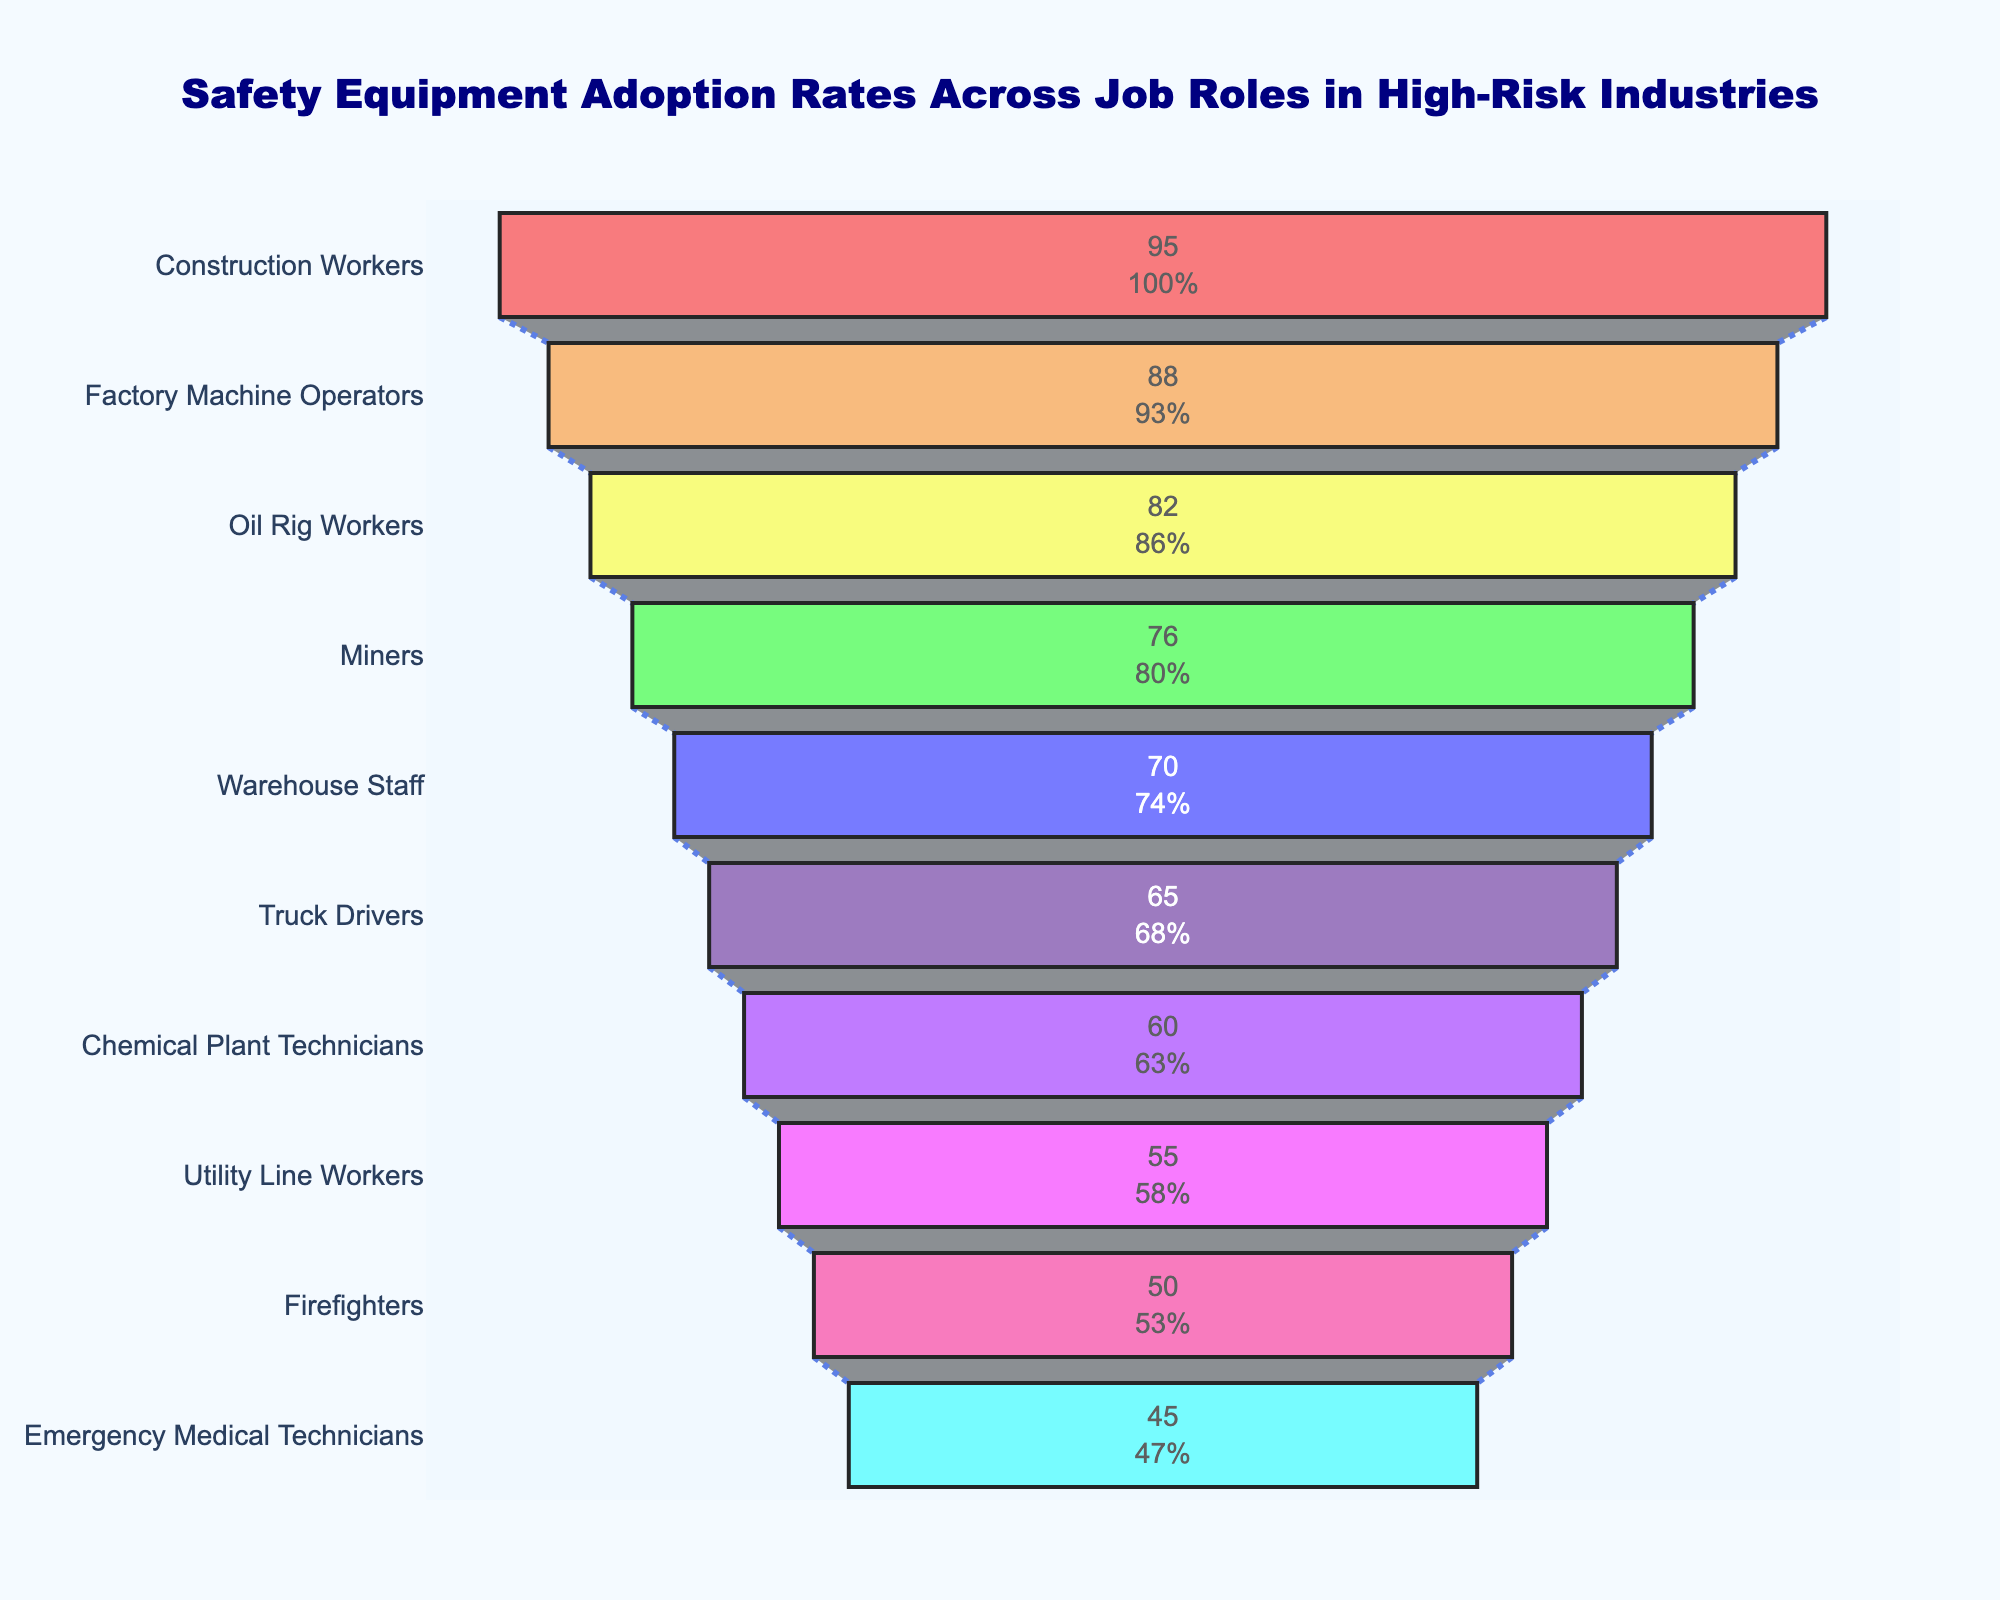What is the title of the chart? The title of the chart is usually placed at the top and provides an overview of what the chart represents. In this case, the title is "Safety Equipment Adoption Rates Across Job Roles in High-Risk Industries".
Answer: Safety Equipment Adoption Rates Across Job Roles in High-Risk Industries How many job roles are included in the funnel chart? By visually counting the distinct sections or categories listed on the left side of the chart, each representing a job role, one can determine the number of job roles included. In this case, there are ten.
Answer: 10 Which job role has the highest adoption rate for safety equipment? The funnel chart descends from the highest to the lowest adoption rate. The top category represents the job role with the highest rate, which is "Construction Workers" with 95%.
Answer: Construction Workers Which job role has the lowest adoption rate for safety equipment? The lowest adoption rate is shown at the bottom of the funnel chart. In this case, "Emergency Medical Technicians" are at the bottom, indicating the lowest adoption rate of 45%.
Answer: Emergency Medical Technicians What is the total percentage difference in adoption rates between Construction Workers and Emergency Medical Technicians? To find the difference, subtract the lower value (45% for Emergency Medical Technicians) from the higher value (95% for Construction Workers): 95% - 45% = 50%.
Answer: 50% Which color is used for the category "Miners"? Each section of the funnel chart is colored distinctively. By referring to the section labeled "Miners", it is colored in a green hue.
Answer: Green What is the average adoption rate across all listed job roles? To calculate the average adoption rate, sum all the adoption rates and divide by the number of job roles. The sum is 95 + 88 + 82 + 76 + 70 + 65 + 60 + 55 + 50 + 45 = 686. Then, divide by 10 (the number of roles): 686 / 10 = 68.6%.
Answer: 68.6% How does the adoption rate for Oil Rig Workers compare to that of Warehouse Staff? By locating both categories on the funnel chart, we can see that Oil Rig Workers have an adoption rate of 82%, while Warehouse Staff have a rate of 70%. Thus, Oil Rig Workers have a higher adoption rate.
Answer: Oil Rig Workers have a higher rate What percent of the initial group do Truck Drivers account for in terms of safety equipment adoption? The funnel chart includes this information graphically within each section. Truck Drivers, with an adoption rate of 65%, account for a certain percentage of the initial group.
Answer: This requires identifying percentage on the figure, which is not provided in the data directly Are there any job roles with an adoption rate below 50%? By examining the chart, we see that "Firefighters" and "Emergency Medical Technicians" have adoption rates below 50%, specifically 50% and 45%, respectively.
Answer: Yes, two roles 